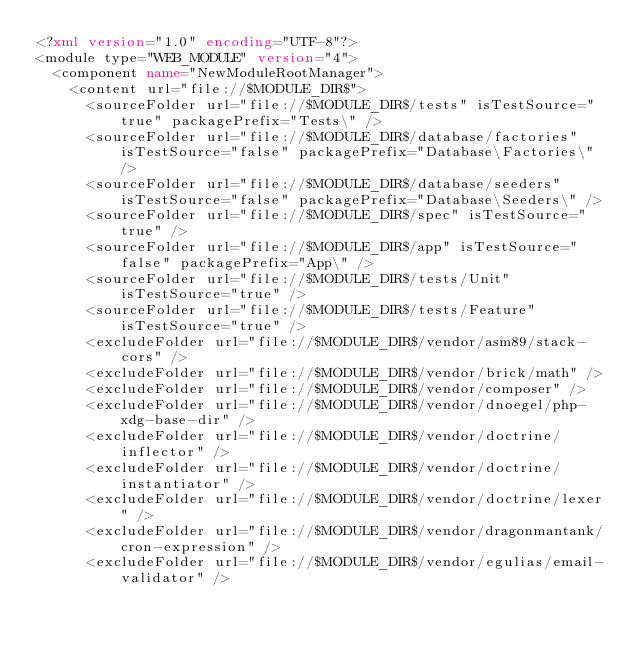<code> <loc_0><loc_0><loc_500><loc_500><_XML_><?xml version="1.0" encoding="UTF-8"?>
<module type="WEB_MODULE" version="4">
  <component name="NewModuleRootManager">
    <content url="file://$MODULE_DIR$">
      <sourceFolder url="file://$MODULE_DIR$/tests" isTestSource="true" packagePrefix="Tests\" />
      <sourceFolder url="file://$MODULE_DIR$/database/factories" isTestSource="false" packagePrefix="Database\Factories\" />
      <sourceFolder url="file://$MODULE_DIR$/database/seeders" isTestSource="false" packagePrefix="Database\Seeders\" />
      <sourceFolder url="file://$MODULE_DIR$/spec" isTestSource="true" />
      <sourceFolder url="file://$MODULE_DIR$/app" isTestSource="false" packagePrefix="App\" />
      <sourceFolder url="file://$MODULE_DIR$/tests/Unit" isTestSource="true" />
      <sourceFolder url="file://$MODULE_DIR$/tests/Feature" isTestSource="true" />
      <excludeFolder url="file://$MODULE_DIR$/vendor/asm89/stack-cors" />
      <excludeFolder url="file://$MODULE_DIR$/vendor/brick/math" />
      <excludeFolder url="file://$MODULE_DIR$/vendor/composer" />
      <excludeFolder url="file://$MODULE_DIR$/vendor/dnoegel/php-xdg-base-dir" />
      <excludeFolder url="file://$MODULE_DIR$/vendor/doctrine/inflector" />
      <excludeFolder url="file://$MODULE_DIR$/vendor/doctrine/instantiator" />
      <excludeFolder url="file://$MODULE_DIR$/vendor/doctrine/lexer" />
      <excludeFolder url="file://$MODULE_DIR$/vendor/dragonmantank/cron-expression" />
      <excludeFolder url="file://$MODULE_DIR$/vendor/egulias/email-validator" /></code> 